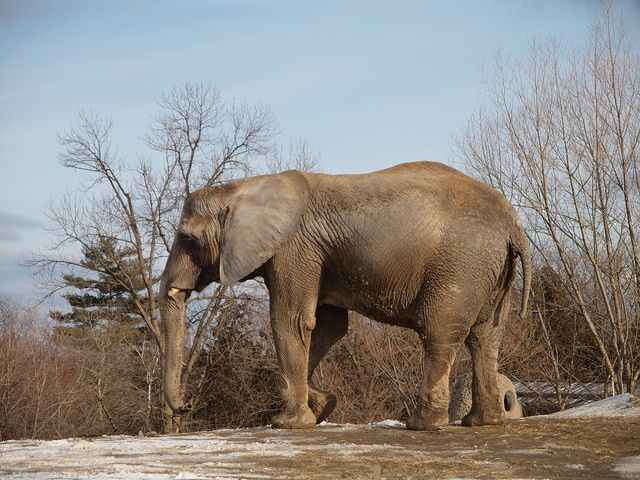Describe the objects in this image and their specific colors. I can see a elephant in gray, tan, black, and maroon tones in this image. 